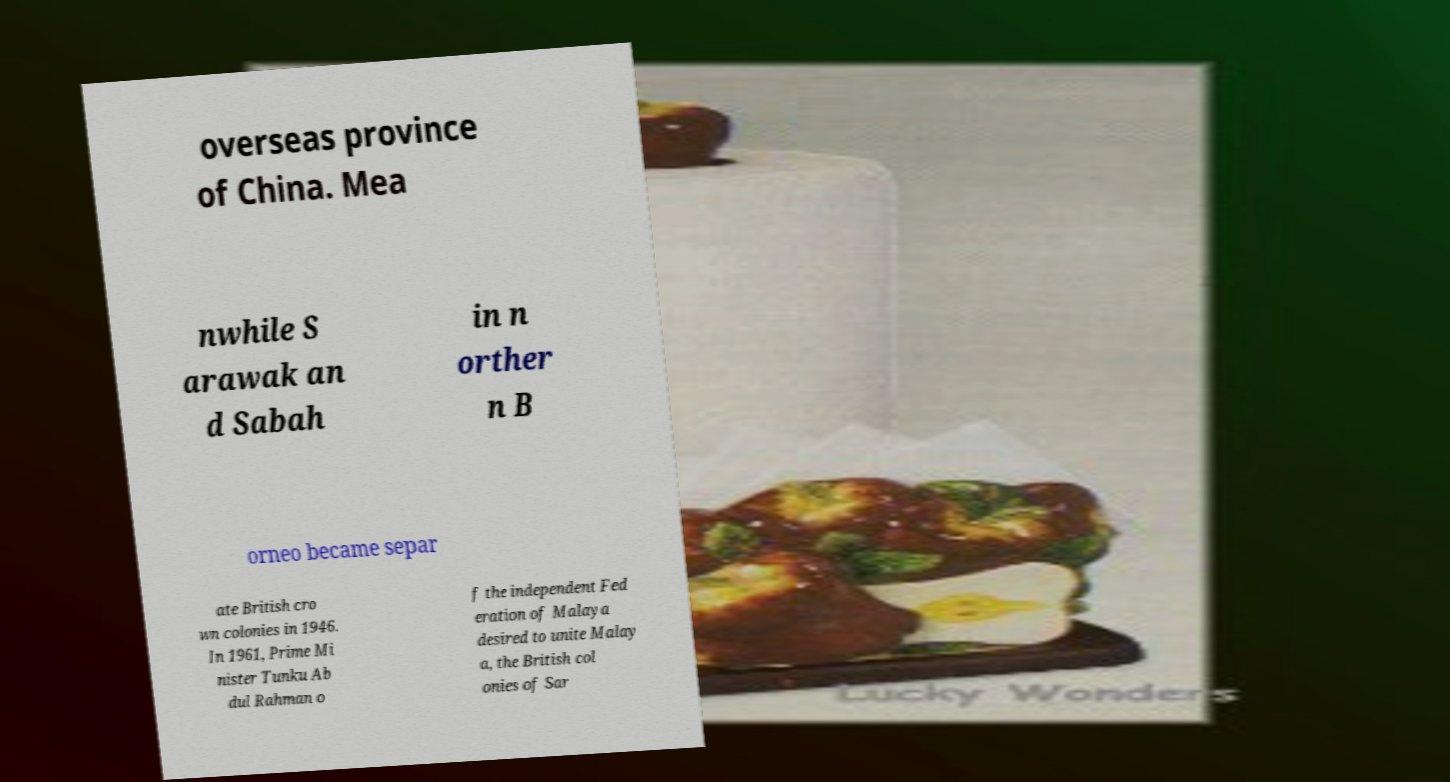Can you accurately transcribe the text from the provided image for me? overseas province of China. Mea nwhile S arawak an d Sabah in n orther n B orneo became separ ate British cro wn colonies in 1946. In 1961, Prime Mi nister Tunku Ab dul Rahman o f the independent Fed eration of Malaya desired to unite Malay a, the British col onies of Sar 